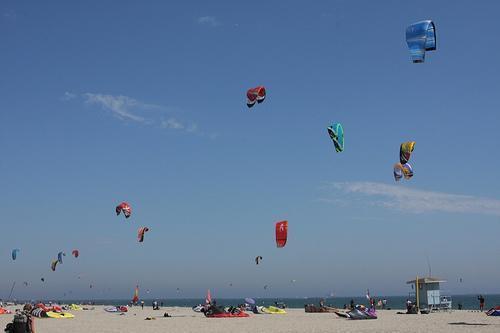What is the building for?
Select the accurate answer and provide explanation: 'Answer: answer
Rationale: rationale.'
Options: Library, church, lifeguard, hospital. Answer: lifeguard.
Rationale: The building gives a good vantage of the beach, while protecting the person from the elements. 